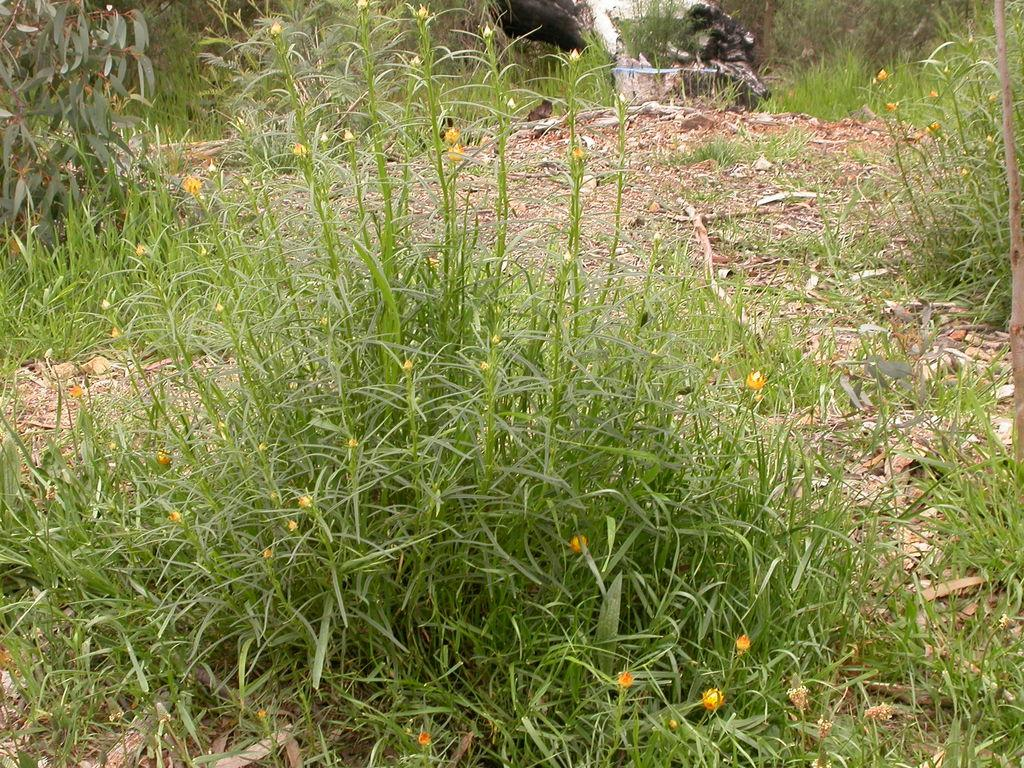What type of vegetation is present on the land in the image? There is grass on the land in the image. What can be seen in the distance in the image? There are trees visible in the background of the image. How many rings are visible on the grass in the image? There are no rings present on the grass in the image. 